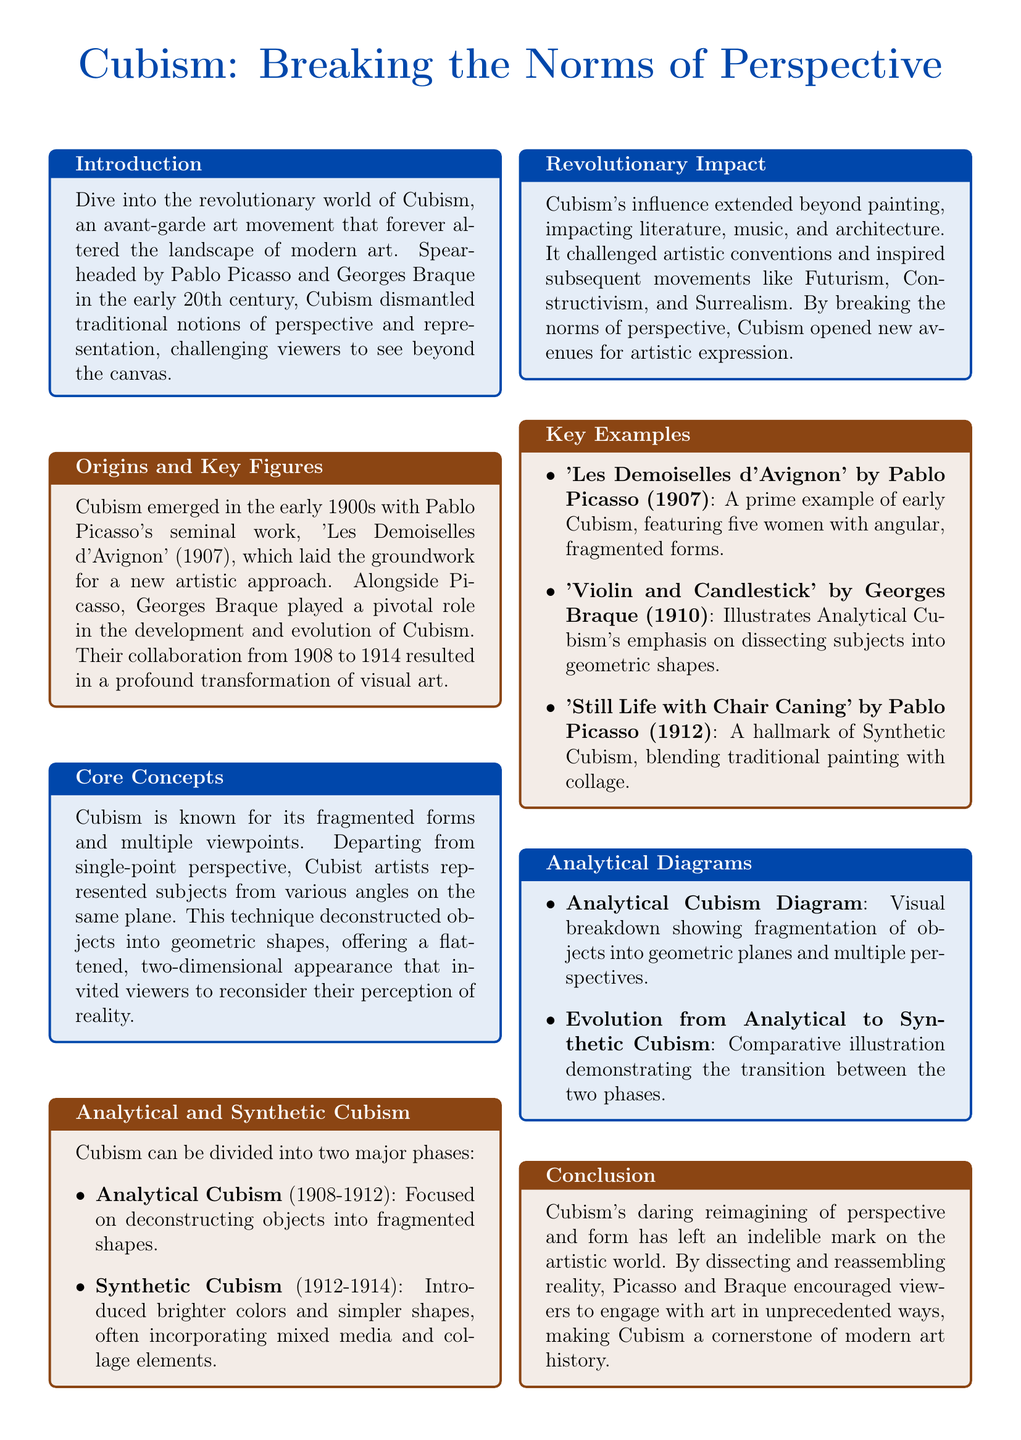What is the name of the art movement discussed? The flyer centers around the Cubism art movement, highlighting its significance in modern art.
Answer: Cubism Who are the two key figures associated with Cubism? The document mentions Pablo Picasso and Georges Braque as the pivotal figures in the development of Cubism.
Answer: Picasso and Braque What year was 'Les Demoiselles d'Avignon' created? The flyer states that Picasso's 'Les Demoiselles d'Avignon' was created in 1907, marking a key moment in Cubism's history.
Answer: 1907 What are the two phases of Cubism mentioned? The flyer distinguishes between Analytical Cubism and Synthetic Cubism, highlighting the evolution within the movement.
Answer: Analytical and Synthetic What technique distinguishes Cubist representation? The flyer notes that Cubism is known for its "fragmented forms and multiple viewpoints," which was a radical departure from traditional perspectives.
Answer: Fragmented forms and multiple viewpoints What impact did Cubism have on other disciplines? The document claims that Cubism influenced literature, music, and architecture, showcasing its broader cultural impact.
Answer: Literature, music, and architecture What is one example of a Synthetic Cubism artwork? The flyer provides 'Still Life with Chair Caning' by Pablo Picasso as a hallmark of Synthetic Cubism, highlighting its mixed media approach.
Answer: Still Life with Chair Caning How is Analytical Cubism characterized? The document states that Analytical Cubism focuses on deconstructing objects into fragmented shapes, illustrating its specific approach.
Answer: Deconstructing objects into fragmented shapes What visual aid is included to explain Analytical Cubism? The flyer mentions an "Analytical Cubism Diagram" which visually breaks down the concept of fragmentation and perspectives.
Answer: Analytical Cubism Diagram 